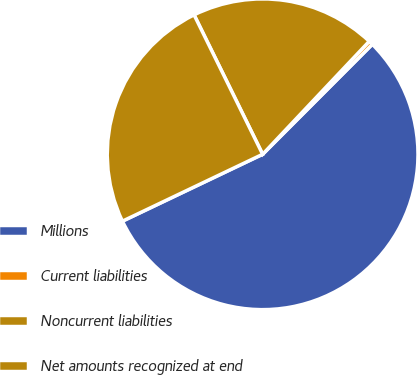<chart> <loc_0><loc_0><loc_500><loc_500><pie_chart><fcel>Millions<fcel>Current liabilities<fcel>Noncurrent liabilities<fcel>Net amounts recognized at end<nl><fcel>55.43%<fcel>0.44%<fcel>19.31%<fcel>24.81%<nl></chart> 